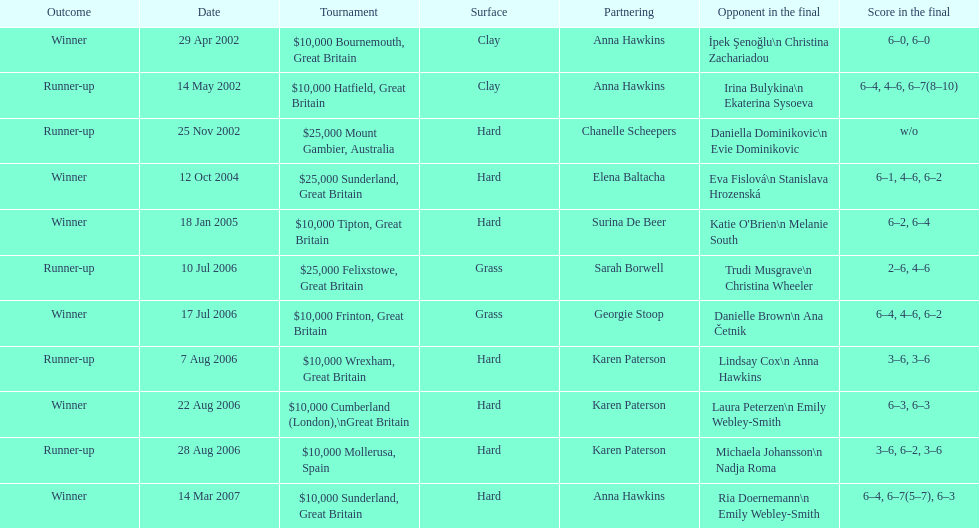How many events has jane o'donoghue competed in throughout her career? 11. 